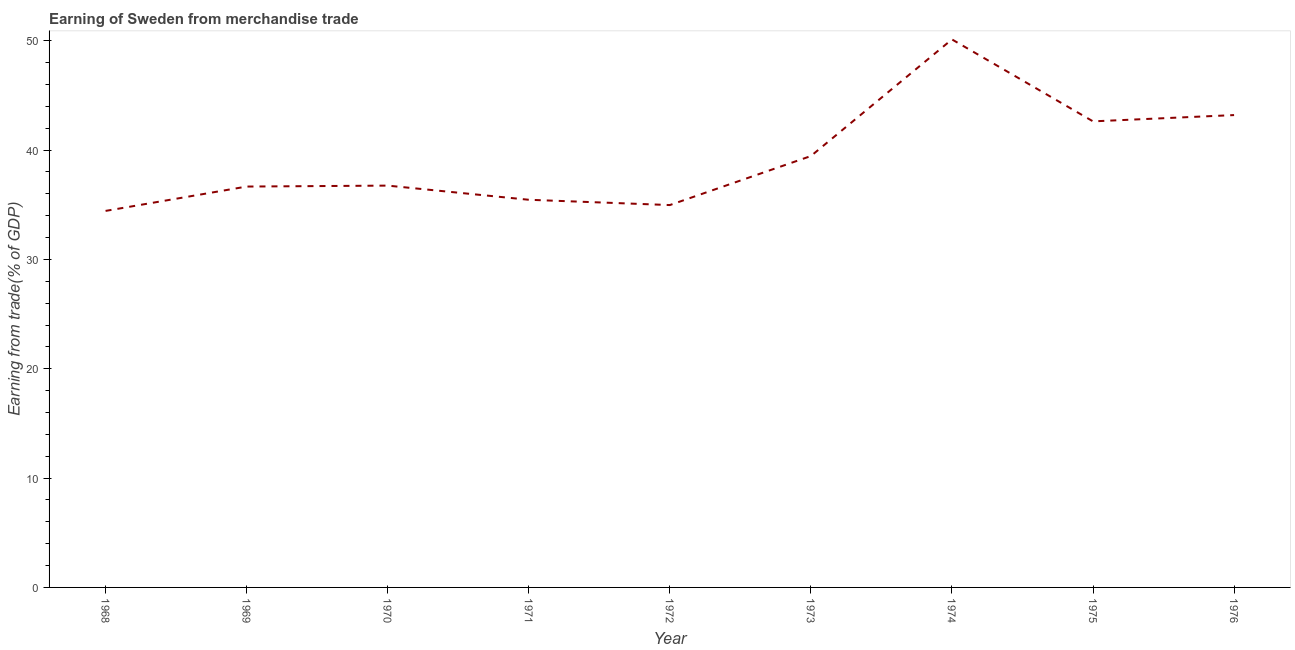What is the earning from merchandise trade in 1974?
Provide a succinct answer. 50.12. Across all years, what is the maximum earning from merchandise trade?
Ensure brevity in your answer.  50.12. Across all years, what is the minimum earning from merchandise trade?
Offer a terse response. 34.44. In which year was the earning from merchandise trade maximum?
Give a very brief answer. 1974. In which year was the earning from merchandise trade minimum?
Provide a succinct answer. 1968. What is the sum of the earning from merchandise trade?
Give a very brief answer. 353.69. What is the difference between the earning from merchandise trade in 1972 and 1975?
Give a very brief answer. -7.66. What is the average earning from merchandise trade per year?
Provide a short and direct response. 39.3. What is the median earning from merchandise trade?
Offer a terse response. 36.75. In how many years, is the earning from merchandise trade greater than 8 %?
Make the answer very short. 9. What is the ratio of the earning from merchandise trade in 1968 to that in 1973?
Provide a short and direct response. 0.87. Is the earning from merchandise trade in 1972 less than that in 1973?
Your answer should be compact. Yes. Is the difference between the earning from merchandise trade in 1973 and 1975 greater than the difference between any two years?
Provide a succinct answer. No. What is the difference between the highest and the second highest earning from merchandise trade?
Your response must be concise. 6.92. What is the difference between the highest and the lowest earning from merchandise trade?
Ensure brevity in your answer.  15.69. In how many years, is the earning from merchandise trade greater than the average earning from merchandise trade taken over all years?
Offer a terse response. 4. How many years are there in the graph?
Your answer should be very brief. 9. Are the values on the major ticks of Y-axis written in scientific E-notation?
Give a very brief answer. No. Does the graph contain any zero values?
Your answer should be compact. No. What is the title of the graph?
Your answer should be compact. Earning of Sweden from merchandise trade. What is the label or title of the X-axis?
Offer a very short reply. Year. What is the label or title of the Y-axis?
Provide a short and direct response. Earning from trade(% of GDP). What is the Earning from trade(% of GDP) of 1968?
Provide a short and direct response. 34.44. What is the Earning from trade(% of GDP) of 1969?
Your answer should be very brief. 36.66. What is the Earning from trade(% of GDP) of 1970?
Make the answer very short. 36.75. What is the Earning from trade(% of GDP) of 1971?
Your response must be concise. 35.46. What is the Earning from trade(% of GDP) in 1972?
Your response must be concise. 34.97. What is the Earning from trade(% of GDP) in 1973?
Your response must be concise. 39.46. What is the Earning from trade(% of GDP) in 1974?
Ensure brevity in your answer.  50.12. What is the Earning from trade(% of GDP) in 1975?
Offer a very short reply. 42.63. What is the Earning from trade(% of GDP) in 1976?
Give a very brief answer. 43.2. What is the difference between the Earning from trade(% of GDP) in 1968 and 1969?
Offer a terse response. -2.23. What is the difference between the Earning from trade(% of GDP) in 1968 and 1970?
Your answer should be compact. -2.31. What is the difference between the Earning from trade(% of GDP) in 1968 and 1971?
Make the answer very short. -1.02. What is the difference between the Earning from trade(% of GDP) in 1968 and 1972?
Make the answer very short. -0.53. What is the difference between the Earning from trade(% of GDP) in 1968 and 1973?
Make the answer very short. -5.02. What is the difference between the Earning from trade(% of GDP) in 1968 and 1974?
Your response must be concise. -15.69. What is the difference between the Earning from trade(% of GDP) in 1968 and 1975?
Provide a short and direct response. -8.19. What is the difference between the Earning from trade(% of GDP) in 1968 and 1976?
Your answer should be very brief. -8.77. What is the difference between the Earning from trade(% of GDP) in 1969 and 1970?
Ensure brevity in your answer.  -0.09. What is the difference between the Earning from trade(% of GDP) in 1969 and 1971?
Offer a terse response. 1.21. What is the difference between the Earning from trade(% of GDP) in 1969 and 1972?
Give a very brief answer. 1.69. What is the difference between the Earning from trade(% of GDP) in 1969 and 1973?
Keep it short and to the point. -2.79. What is the difference between the Earning from trade(% of GDP) in 1969 and 1974?
Your response must be concise. -13.46. What is the difference between the Earning from trade(% of GDP) in 1969 and 1975?
Your response must be concise. -5.96. What is the difference between the Earning from trade(% of GDP) in 1969 and 1976?
Give a very brief answer. -6.54. What is the difference between the Earning from trade(% of GDP) in 1970 and 1971?
Keep it short and to the point. 1.29. What is the difference between the Earning from trade(% of GDP) in 1970 and 1972?
Your answer should be very brief. 1.78. What is the difference between the Earning from trade(% of GDP) in 1970 and 1973?
Offer a very short reply. -2.7. What is the difference between the Earning from trade(% of GDP) in 1970 and 1974?
Give a very brief answer. -13.37. What is the difference between the Earning from trade(% of GDP) in 1970 and 1975?
Offer a very short reply. -5.88. What is the difference between the Earning from trade(% of GDP) in 1970 and 1976?
Provide a succinct answer. -6.45. What is the difference between the Earning from trade(% of GDP) in 1971 and 1972?
Provide a short and direct response. 0.48. What is the difference between the Earning from trade(% of GDP) in 1971 and 1973?
Keep it short and to the point. -4. What is the difference between the Earning from trade(% of GDP) in 1971 and 1974?
Make the answer very short. -14.67. What is the difference between the Earning from trade(% of GDP) in 1971 and 1975?
Make the answer very short. -7.17. What is the difference between the Earning from trade(% of GDP) in 1971 and 1976?
Give a very brief answer. -7.75. What is the difference between the Earning from trade(% of GDP) in 1972 and 1973?
Give a very brief answer. -4.48. What is the difference between the Earning from trade(% of GDP) in 1972 and 1974?
Offer a terse response. -15.15. What is the difference between the Earning from trade(% of GDP) in 1972 and 1975?
Your answer should be very brief. -7.66. What is the difference between the Earning from trade(% of GDP) in 1972 and 1976?
Offer a terse response. -8.23. What is the difference between the Earning from trade(% of GDP) in 1973 and 1974?
Your answer should be very brief. -10.67. What is the difference between the Earning from trade(% of GDP) in 1973 and 1975?
Give a very brief answer. -3.17. What is the difference between the Earning from trade(% of GDP) in 1973 and 1976?
Your response must be concise. -3.75. What is the difference between the Earning from trade(% of GDP) in 1974 and 1975?
Ensure brevity in your answer.  7.5. What is the difference between the Earning from trade(% of GDP) in 1974 and 1976?
Provide a short and direct response. 6.92. What is the difference between the Earning from trade(% of GDP) in 1975 and 1976?
Ensure brevity in your answer.  -0.58. What is the ratio of the Earning from trade(% of GDP) in 1968 to that in 1969?
Your answer should be compact. 0.94. What is the ratio of the Earning from trade(% of GDP) in 1968 to that in 1970?
Provide a short and direct response. 0.94. What is the ratio of the Earning from trade(% of GDP) in 1968 to that in 1972?
Ensure brevity in your answer.  0.98. What is the ratio of the Earning from trade(% of GDP) in 1968 to that in 1973?
Provide a short and direct response. 0.87. What is the ratio of the Earning from trade(% of GDP) in 1968 to that in 1974?
Your response must be concise. 0.69. What is the ratio of the Earning from trade(% of GDP) in 1968 to that in 1975?
Give a very brief answer. 0.81. What is the ratio of the Earning from trade(% of GDP) in 1968 to that in 1976?
Your answer should be very brief. 0.8. What is the ratio of the Earning from trade(% of GDP) in 1969 to that in 1971?
Provide a short and direct response. 1.03. What is the ratio of the Earning from trade(% of GDP) in 1969 to that in 1972?
Keep it short and to the point. 1.05. What is the ratio of the Earning from trade(% of GDP) in 1969 to that in 1973?
Your response must be concise. 0.93. What is the ratio of the Earning from trade(% of GDP) in 1969 to that in 1974?
Ensure brevity in your answer.  0.73. What is the ratio of the Earning from trade(% of GDP) in 1969 to that in 1975?
Give a very brief answer. 0.86. What is the ratio of the Earning from trade(% of GDP) in 1969 to that in 1976?
Offer a terse response. 0.85. What is the ratio of the Earning from trade(% of GDP) in 1970 to that in 1972?
Provide a short and direct response. 1.05. What is the ratio of the Earning from trade(% of GDP) in 1970 to that in 1974?
Offer a terse response. 0.73. What is the ratio of the Earning from trade(% of GDP) in 1970 to that in 1975?
Provide a short and direct response. 0.86. What is the ratio of the Earning from trade(% of GDP) in 1970 to that in 1976?
Offer a very short reply. 0.85. What is the ratio of the Earning from trade(% of GDP) in 1971 to that in 1973?
Keep it short and to the point. 0.9. What is the ratio of the Earning from trade(% of GDP) in 1971 to that in 1974?
Your response must be concise. 0.71. What is the ratio of the Earning from trade(% of GDP) in 1971 to that in 1975?
Make the answer very short. 0.83. What is the ratio of the Earning from trade(% of GDP) in 1971 to that in 1976?
Offer a very short reply. 0.82. What is the ratio of the Earning from trade(% of GDP) in 1972 to that in 1973?
Provide a succinct answer. 0.89. What is the ratio of the Earning from trade(% of GDP) in 1972 to that in 1974?
Offer a very short reply. 0.7. What is the ratio of the Earning from trade(% of GDP) in 1972 to that in 1975?
Provide a short and direct response. 0.82. What is the ratio of the Earning from trade(% of GDP) in 1972 to that in 1976?
Provide a succinct answer. 0.81. What is the ratio of the Earning from trade(% of GDP) in 1973 to that in 1974?
Offer a terse response. 0.79. What is the ratio of the Earning from trade(% of GDP) in 1973 to that in 1975?
Your answer should be compact. 0.93. What is the ratio of the Earning from trade(% of GDP) in 1973 to that in 1976?
Your response must be concise. 0.91. What is the ratio of the Earning from trade(% of GDP) in 1974 to that in 1975?
Your answer should be very brief. 1.18. What is the ratio of the Earning from trade(% of GDP) in 1974 to that in 1976?
Ensure brevity in your answer.  1.16. What is the ratio of the Earning from trade(% of GDP) in 1975 to that in 1976?
Offer a very short reply. 0.99. 